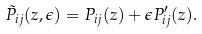Convert formula to latex. <formula><loc_0><loc_0><loc_500><loc_500>\tilde { P } _ { i j } ( z , \epsilon ) = P _ { i j } ( z ) + \epsilon P ^ { \prime } _ { i j } ( z ) .</formula> 